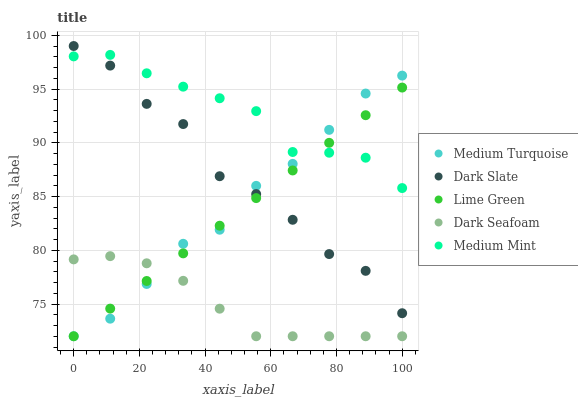Does Dark Seafoam have the minimum area under the curve?
Answer yes or no. Yes. Does Medium Mint have the maximum area under the curve?
Answer yes or no. Yes. Does Dark Slate have the minimum area under the curve?
Answer yes or no. No. Does Dark Slate have the maximum area under the curve?
Answer yes or no. No. Is Lime Green the smoothest?
Answer yes or no. Yes. Is Dark Slate the roughest?
Answer yes or no. Yes. Is Dark Seafoam the smoothest?
Answer yes or no. No. Is Dark Seafoam the roughest?
Answer yes or no. No. Does Dark Seafoam have the lowest value?
Answer yes or no. Yes. Does Dark Slate have the lowest value?
Answer yes or no. No. Does Dark Slate have the highest value?
Answer yes or no. Yes. Does Dark Seafoam have the highest value?
Answer yes or no. No. Is Dark Seafoam less than Dark Slate?
Answer yes or no. Yes. Is Dark Slate greater than Dark Seafoam?
Answer yes or no. Yes. Does Medium Turquoise intersect Dark Slate?
Answer yes or no. Yes. Is Medium Turquoise less than Dark Slate?
Answer yes or no. No. Is Medium Turquoise greater than Dark Slate?
Answer yes or no. No. Does Dark Seafoam intersect Dark Slate?
Answer yes or no. No. 